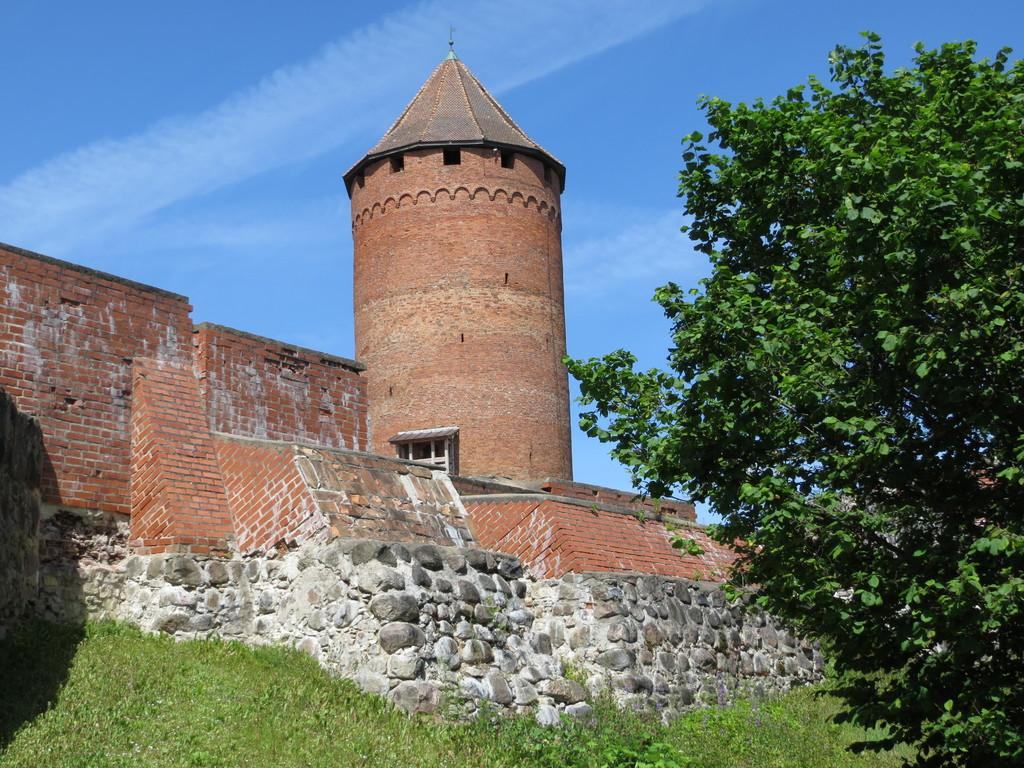What type of structure is present in the image? There is a building in the image. What are the walls made of in the image? The walls are not specified in the image, but they are likely made of a solid material like brick or concrete. What type of vegetation can be seen in the image? There is grass, plants, and trees visible in the image. What is visible in the background of the image? The sky is visible in the background of the image. Can you see a girl sneezing while wearing a collar in the image? There is no girl, sneezing, or collar present in the image. 